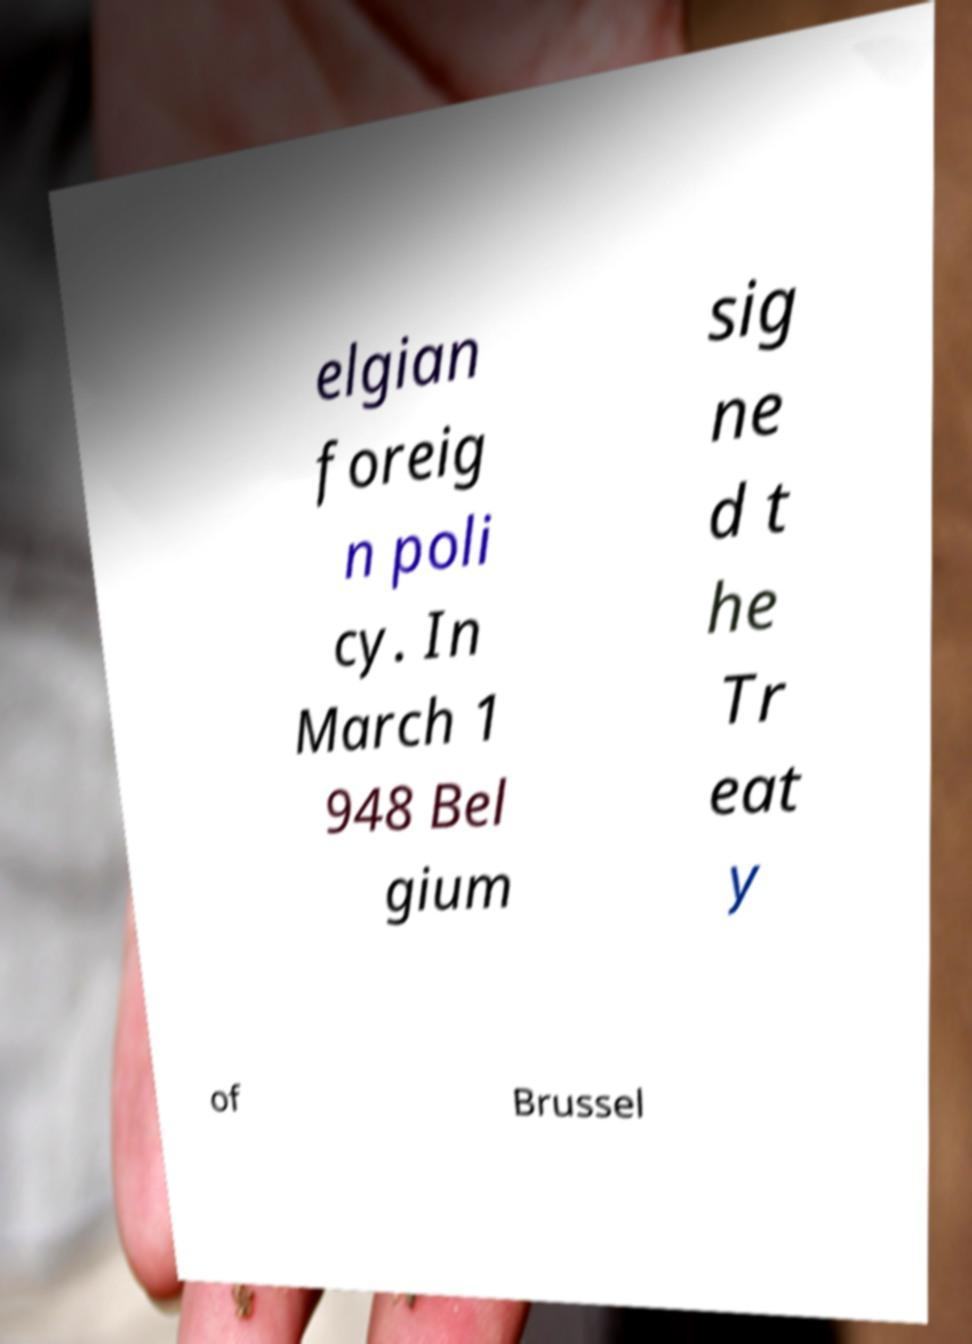Can you accurately transcribe the text from the provided image for me? elgian foreig n poli cy. In March 1 948 Bel gium sig ne d t he Tr eat y of Brussel 